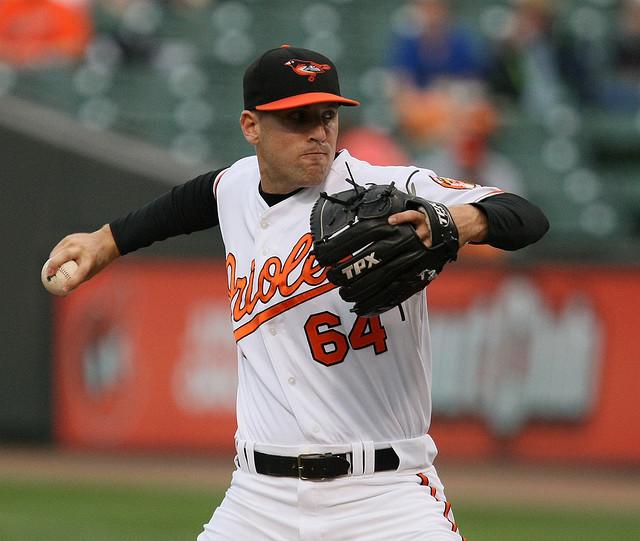What finger is not inside the pitcher's glove?
Answer briefly. Index. What is the number on his uniform?
Concise answer only. 64. What position is this?
Short answer required. Pitcher. 